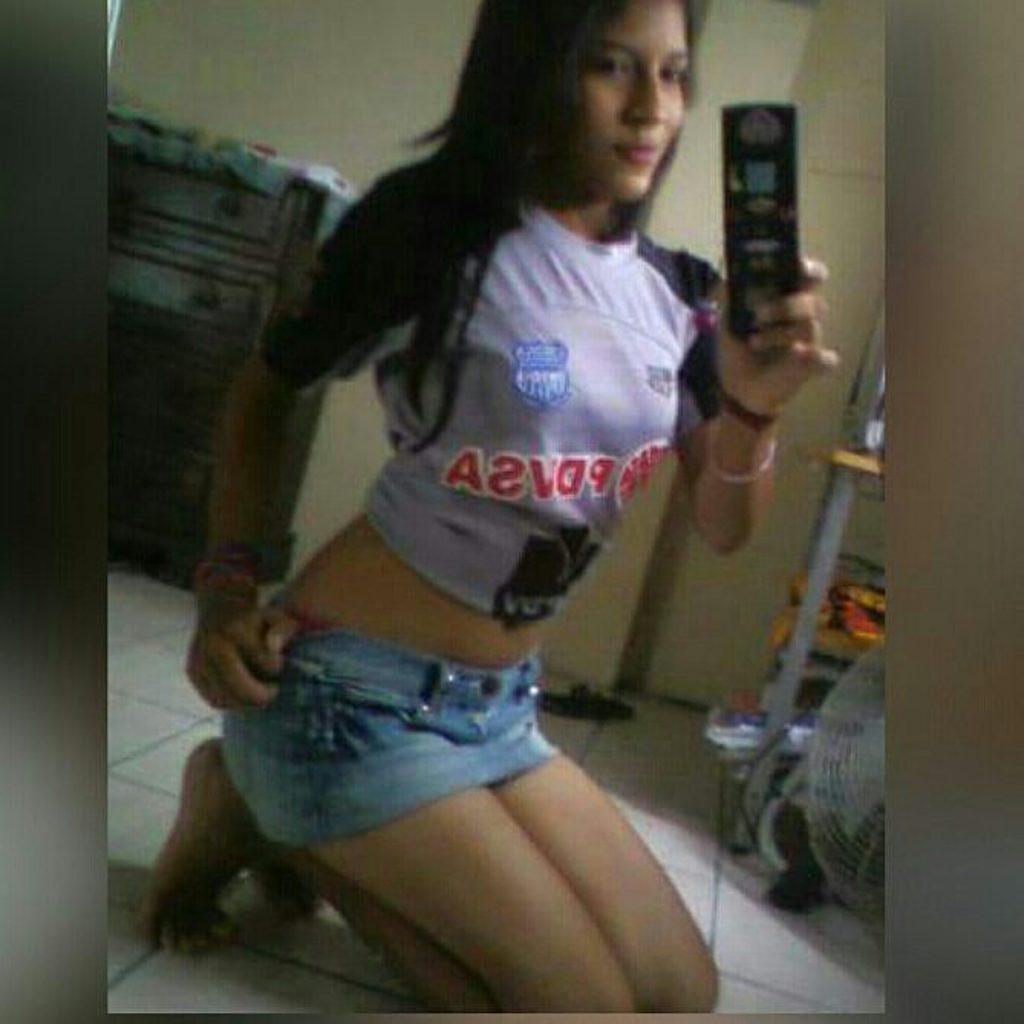Describe this image in one or two sentences. In this image I can see the person holding some object. In the background I can see the cupboard and the wall is in cream color. 